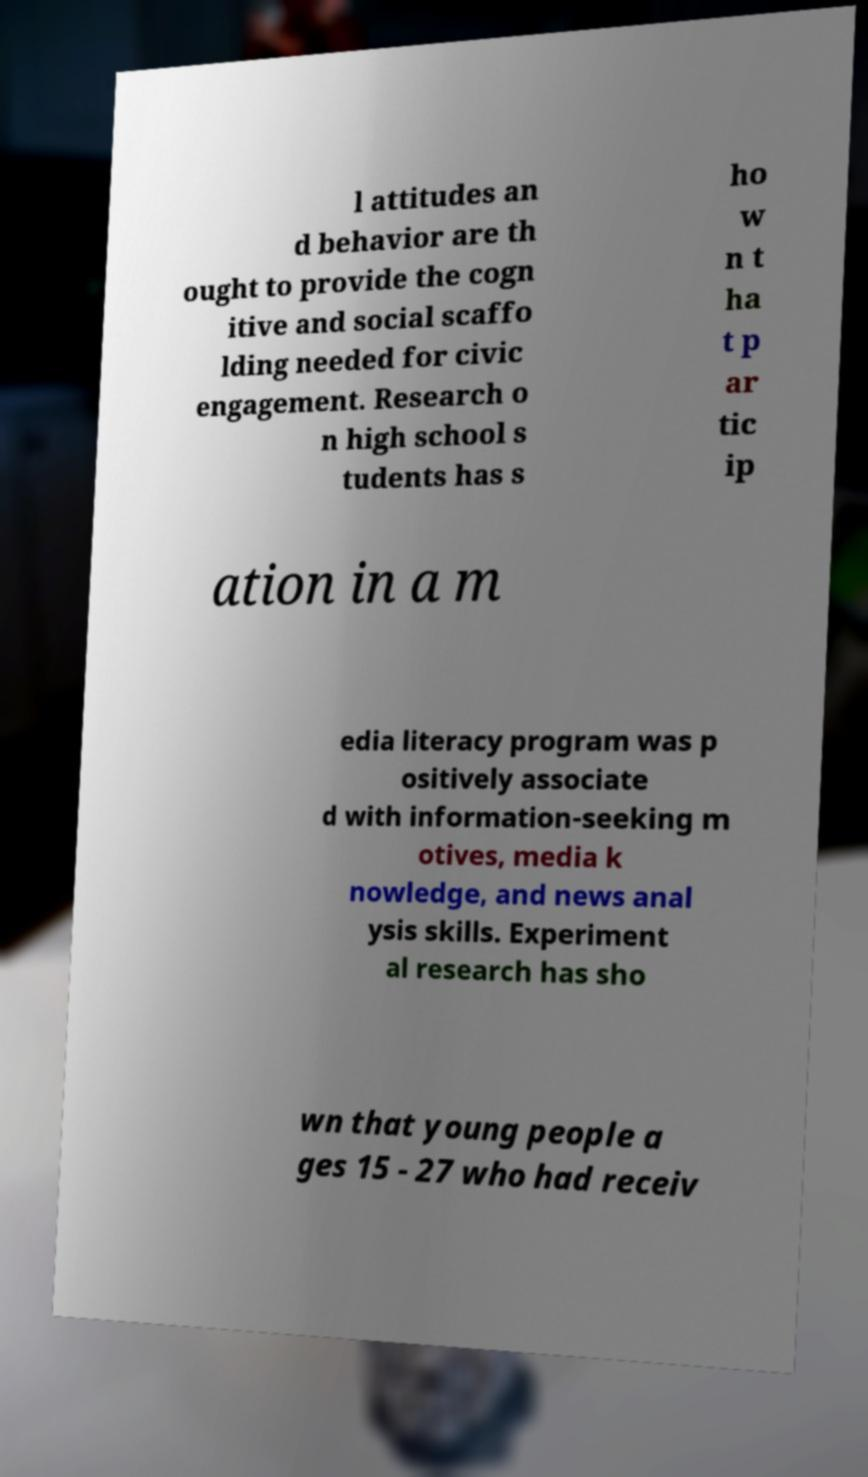Please identify and transcribe the text found in this image. l attitudes an d behavior are th ought to provide the cogn itive and social scaffo lding needed for civic engagement. Research o n high school s tudents has s ho w n t ha t p ar tic ip ation in a m edia literacy program was p ositively associate d with information-seeking m otives, media k nowledge, and news anal ysis skills. Experiment al research has sho wn that young people a ges 15 - 27 who had receiv 